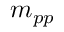Convert formula to latex. <formula><loc_0><loc_0><loc_500><loc_500>m _ { p p }</formula> 